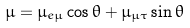Convert formula to latex. <formula><loc_0><loc_0><loc_500><loc_500>\mu = \mu _ { e \mu } \cos \theta + \mu _ { \mu \tau } \sin \theta</formula> 